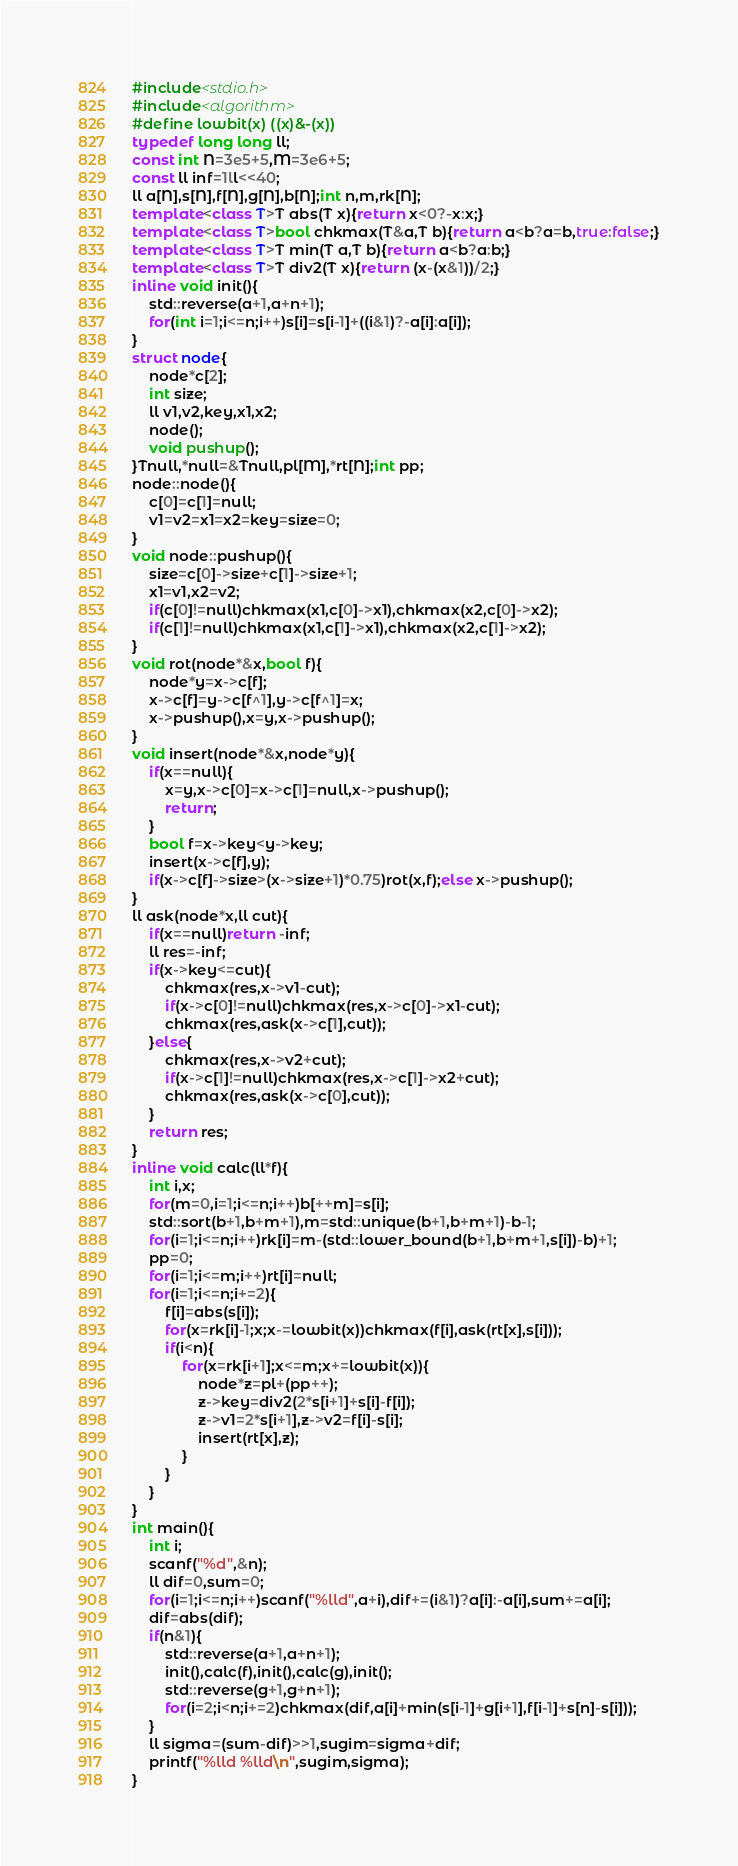<code> <loc_0><loc_0><loc_500><loc_500><_C++_>#include<stdio.h>
#include<algorithm>
#define lowbit(x) ((x)&-(x))
typedef long long ll;
const int N=3e5+5,M=3e6+5;
const ll inf=1ll<<40;
ll a[N],s[N],f[N],g[N],b[N];int n,m,rk[N];
template<class T>T abs(T x){return x<0?-x:x;}
template<class T>bool chkmax(T&a,T b){return a<b?a=b,true:false;}
template<class T>T min(T a,T b){return a<b?a:b;}
template<class T>T div2(T x){return (x-(x&1))/2;}
inline void init(){
	std::reverse(a+1,a+n+1);
	for(int i=1;i<=n;i++)s[i]=s[i-1]+((i&1)?-a[i]:a[i]);
}
struct node{
	node*c[2];
	int size;
	ll v1,v2,key,x1,x2;
	node();
	void pushup();
}Tnull,*null=&Tnull,pl[M],*rt[N];int pp;
node::node(){
	c[0]=c[1]=null;
	v1=v2=x1=x2=key=size=0;
}
void node::pushup(){
	size=c[0]->size+c[1]->size+1;
	x1=v1,x2=v2;
	if(c[0]!=null)chkmax(x1,c[0]->x1),chkmax(x2,c[0]->x2); 
	if(c[1]!=null)chkmax(x1,c[1]->x1),chkmax(x2,c[1]->x2);
}
void rot(node*&x,bool f){
	node*y=x->c[f];
	x->c[f]=y->c[f^1],y->c[f^1]=x;
	x->pushup(),x=y,x->pushup(); 
}
void insert(node*&x,node*y){
	if(x==null){
		x=y,x->c[0]=x->c[1]=null,x->pushup();
		return;
	}
	bool f=x->key<y->key;
	insert(x->c[f],y);
	if(x->c[f]->size>(x->size+1)*0.75)rot(x,f);else x->pushup();
}
ll ask(node*x,ll cut){
	if(x==null)return -inf;
	ll res=-inf;
	if(x->key<=cut){
		chkmax(res,x->v1-cut);
		if(x->c[0]!=null)chkmax(res,x->c[0]->x1-cut);
		chkmax(res,ask(x->c[1],cut));
	}else{
		chkmax(res,x->v2+cut);
		if(x->c[1]!=null)chkmax(res,x->c[1]->x2+cut);
		chkmax(res,ask(x->c[0],cut));
	}
	return res;
}
inline void calc(ll*f){
	int i,x;
	for(m=0,i=1;i<=n;i++)b[++m]=s[i];
	std::sort(b+1,b+m+1),m=std::unique(b+1,b+m+1)-b-1;
	for(i=1;i<=n;i++)rk[i]=m-(std::lower_bound(b+1,b+m+1,s[i])-b)+1;
	pp=0;
	for(i=1;i<=m;i++)rt[i]=null;
	for(i=1;i<=n;i+=2){
		f[i]=abs(s[i]);
		for(x=rk[i]-1;x;x-=lowbit(x))chkmax(f[i],ask(rt[x],s[i]));
		if(i<n){
			for(x=rk[i+1];x<=m;x+=lowbit(x)){
				node*z=pl+(pp++);
				z->key=div2(2*s[i+1]+s[i]-f[i]);
				z->v1=2*s[i+1],z->v2=f[i]-s[i];
				insert(rt[x],z);
			}
		}
	}
}
int main(){
	int i;
	scanf("%d",&n);
	ll dif=0,sum=0;
	for(i=1;i<=n;i++)scanf("%lld",a+i),dif+=(i&1)?a[i]:-a[i],sum+=a[i];
	dif=abs(dif);
	if(n&1){
		std::reverse(a+1,a+n+1);
		init(),calc(f),init(),calc(g),init();
		std::reverse(g+1,g+n+1);
		for(i=2;i<n;i+=2)chkmax(dif,a[i]+min(s[i-1]+g[i+1],f[i-1]+s[n]-s[i]));
	}
	ll sigma=(sum-dif)>>1,sugim=sigma+dif;
	printf("%lld %lld\n",sugim,sigma);
}</code> 